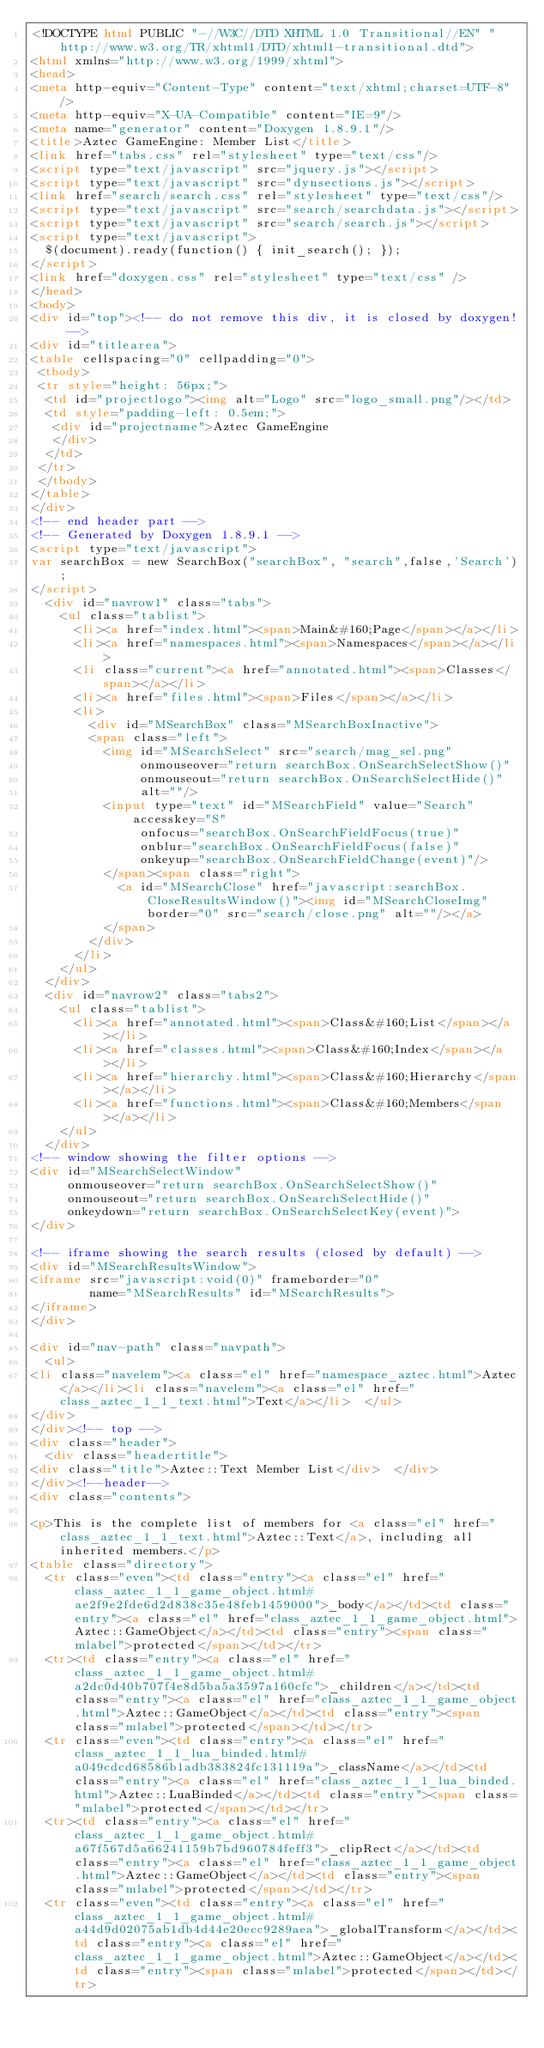Convert code to text. <code><loc_0><loc_0><loc_500><loc_500><_HTML_><!DOCTYPE html PUBLIC "-//W3C//DTD XHTML 1.0 Transitional//EN" "http://www.w3.org/TR/xhtml1/DTD/xhtml1-transitional.dtd">
<html xmlns="http://www.w3.org/1999/xhtml">
<head>
<meta http-equiv="Content-Type" content="text/xhtml;charset=UTF-8"/>
<meta http-equiv="X-UA-Compatible" content="IE=9"/>
<meta name="generator" content="Doxygen 1.8.9.1"/>
<title>Aztec GameEngine: Member List</title>
<link href="tabs.css" rel="stylesheet" type="text/css"/>
<script type="text/javascript" src="jquery.js"></script>
<script type="text/javascript" src="dynsections.js"></script>
<link href="search/search.css" rel="stylesheet" type="text/css"/>
<script type="text/javascript" src="search/searchdata.js"></script>
<script type="text/javascript" src="search/search.js"></script>
<script type="text/javascript">
  $(document).ready(function() { init_search(); });
</script>
<link href="doxygen.css" rel="stylesheet" type="text/css" />
</head>
<body>
<div id="top"><!-- do not remove this div, it is closed by doxygen! -->
<div id="titlearea">
<table cellspacing="0" cellpadding="0">
 <tbody>
 <tr style="height: 56px;">
  <td id="projectlogo"><img alt="Logo" src="logo_small.png"/></td>
  <td style="padding-left: 0.5em;">
   <div id="projectname">Aztec GameEngine
   </div>
  </td>
 </tr>
 </tbody>
</table>
</div>
<!-- end header part -->
<!-- Generated by Doxygen 1.8.9.1 -->
<script type="text/javascript">
var searchBox = new SearchBox("searchBox", "search",false,'Search');
</script>
  <div id="navrow1" class="tabs">
    <ul class="tablist">
      <li><a href="index.html"><span>Main&#160;Page</span></a></li>
      <li><a href="namespaces.html"><span>Namespaces</span></a></li>
      <li class="current"><a href="annotated.html"><span>Classes</span></a></li>
      <li><a href="files.html"><span>Files</span></a></li>
      <li>
        <div id="MSearchBox" class="MSearchBoxInactive">
        <span class="left">
          <img id="MSearchSelect" src="search/mag_sel.png"
               onmouseover="return searchBox.OnSearchSelectShow()"
               onmouseout="return searchBox.OnSearchSelectHide()"
               alt=""/>
          <input type="text" id="MSearchField" value="Search" accesskey="S"
               onfocus="searchBox.OnSearchFieldFocus(true)" 
               onblur="searchBox.OnSearchFieldFocus(false)" 
               onkeyup="searchBox.OnSearchFieldChange(event)"/>
          </span><span class="right">
            <a id="MSearchClose" href="javascript:searchBox.CloseResultsWindow()"><img id="MSearchCloseImg" border="0" src="search/close.png" alt=""/></a>
          </span>
        </div>
      </li>
    </ul>
  </div>
  <div id="navrow2" class="tabs2">
    <ul class="tablist">
      <li><a href="annotated.html"><span>Class&#160;List</span></a></li>
      <li><a href="classes.html"><span>Class&#160;Index</span></a></li>
      <li><a href="hierarchy.html"><span>Class&#160;Hierarchy</span></a></li>
      <li><a href="functions.html"><span>Class&#160;Members</span></a></li>
    </ul>
  </div>
<!-- window showing the filter options -->
<div id="MSearchSelectWindow"
     onmouseover="return searchBox.OnSearchSelectShow()"
     onmouseout="return searchBox.OnSearchSelectHide()"
     onkeydown="return searchBox.OnSearchSelectKey(event)">
</div>

<!-- iframe showing the search results (closed by default) -->
<div id="MSearchResultsWindow">
<iframe src="javascript:void(0)" frameborder="0" 
        name="MSearchResults" id="MSearchResults">
</iframe>
</div>

<div id="nav-path" class="navpath">
  <ul>
<li class="navelem"><a class="el" href="namespace_aztec.html">Aztec</a></li><li class="navelem"><a class="el" href="class_aztec_1_1_text.html">Text</a></li>  </ul>
</div>
</div><!-- top -->
<div class="header">
  <div class="headertitle">
<div class="title">Aztec::Text Member List</div>  </div>
</div><!--header-->
<div class="contents">

<p>This is the complete list of members for <a class="el" href="class_aztec_1_1_text.html">Aztec::Text</a>, including all inherited members.</p>
<table class="directory">
  <tr class="even"><td class="entry"><a class="el" href="class_aztec_1_1_game_object.html#ae2f9e2fde6d2d838c35e48feb1459000">_body</a></td><td class="entry"><a class="el" href="class_aztec_1_1_game_object.html">Aztec::GameObject</a></td><td class="entry"><span class="mlabel">protected</span></td></tr>
  <tr><td class="entry"><a class="el" href="class_aztec_1_1_game_object.html#a2dc0d40b707f4e8d5ba5a3597a160cfc">_children</a></td><td class="entry"><a class="el" href="class_aztec_1_1_game_object.html">Aztec::GameObject</a></td><td class="entry"><span class="mlabel">protected</span></td></tr>
  <tr class="even"><td class="entry"><a class="el" href="class_aztec_1_1_lua_binded.html#a049cdcd68586b1adb383824fc131119a">_className</a></td><td class="entry"><a class="el" href="class_aztec_1_1_lua_binded.html">Aztec::LuaBinded</a></td><td class="entry"><span class="mlabel">protected</span></td></tr>
  <tr><td class="entry"><a class="el" href="class_aztec_1_1_game_object.html#a67f567d5a66241159b7bd960784feff3">_clipRect</a></td><td class="entry"><a class="el" href="class_aztec_1_1_game_object.html">Aztec::GameObject</a></td><td class="entry"><span class="mlabel">protected</span></td></tr>
  <tr class="even"><td class="entry"><a class="el" href="class_aztec_1_1_game_object.html#a44d9d02075ab1db4d44e20ecc9289aea">_globalTransform</a></td><td class="entry"><a class="el" href="class_aztec_1_1_game_object.html">Aztec::GameObject</a></td><td class="entry"><span class="mlabel">protected</span></td></tr></code> 